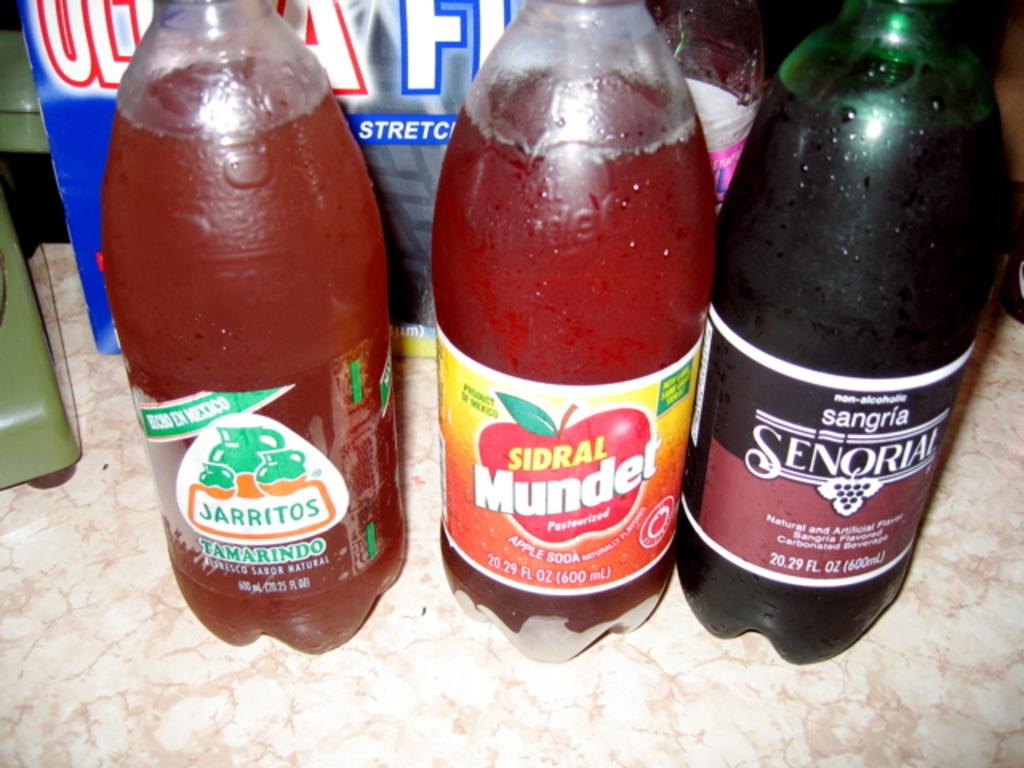<image>
Give a short and clear explanation of the subsequent image. A group of sodas sit on a table with the one to the left being called Jarritos. 